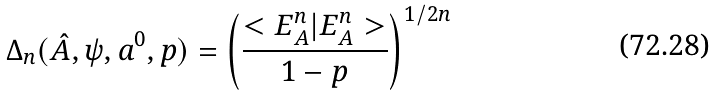<formula> <loc_0><loc_0><loc_500><loc_500>\Delta _ { n } ( \hat { A } , \psi , a ^ { 0 } , p ) = \left ( \frac { < E ^ { n } _ { A } | E ^ { n } _ { A } > } { 1 - p } \right ) ^ { 1 / 2 n }</formula> 